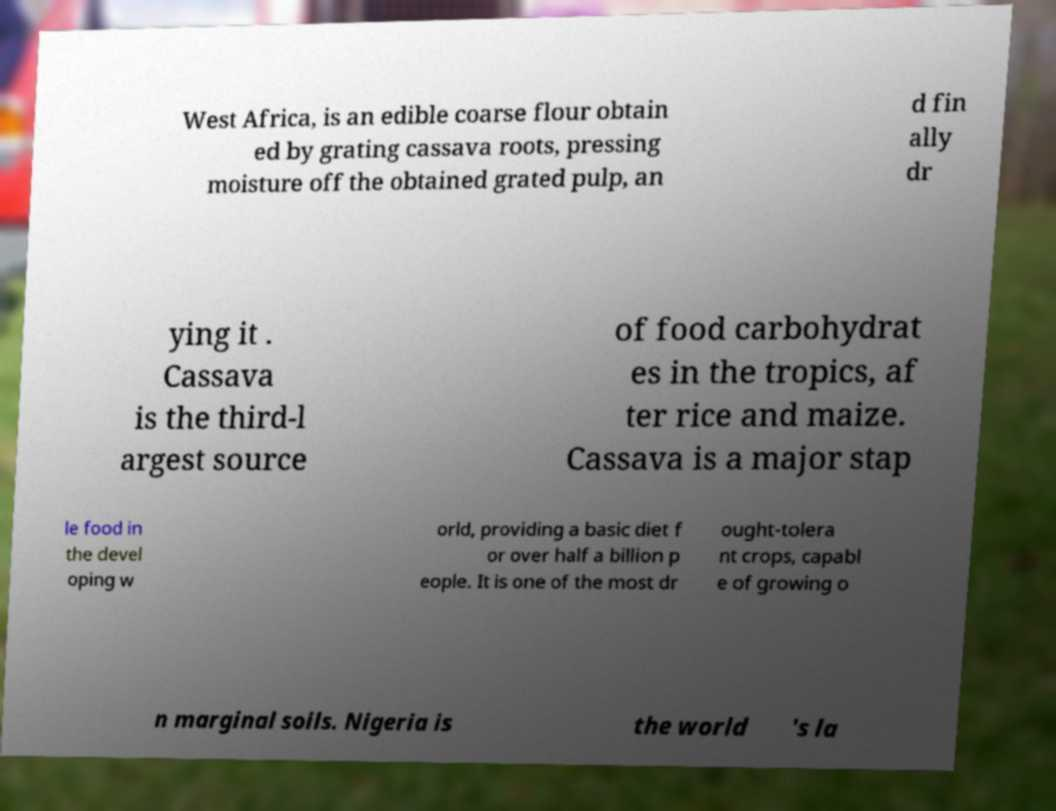Please identify and transcribe the text found in this image. West Africa, is an edible coarse flour obtain ed by grating cassava roots, pressing moisture off the obtained grated pulp, an d fin ally dr ying it . Cassava is the third-l argest source of food carbohydrat es in the tropics, af ter rice and maize. Cassava is a major stap le food in the devel oping w orld, providing a basic diet f or over half a billion p eople. It is one of the most dr ought-tolera nt crops, capabl e of growing o n marginal soils. Nigeria is the world 's la 